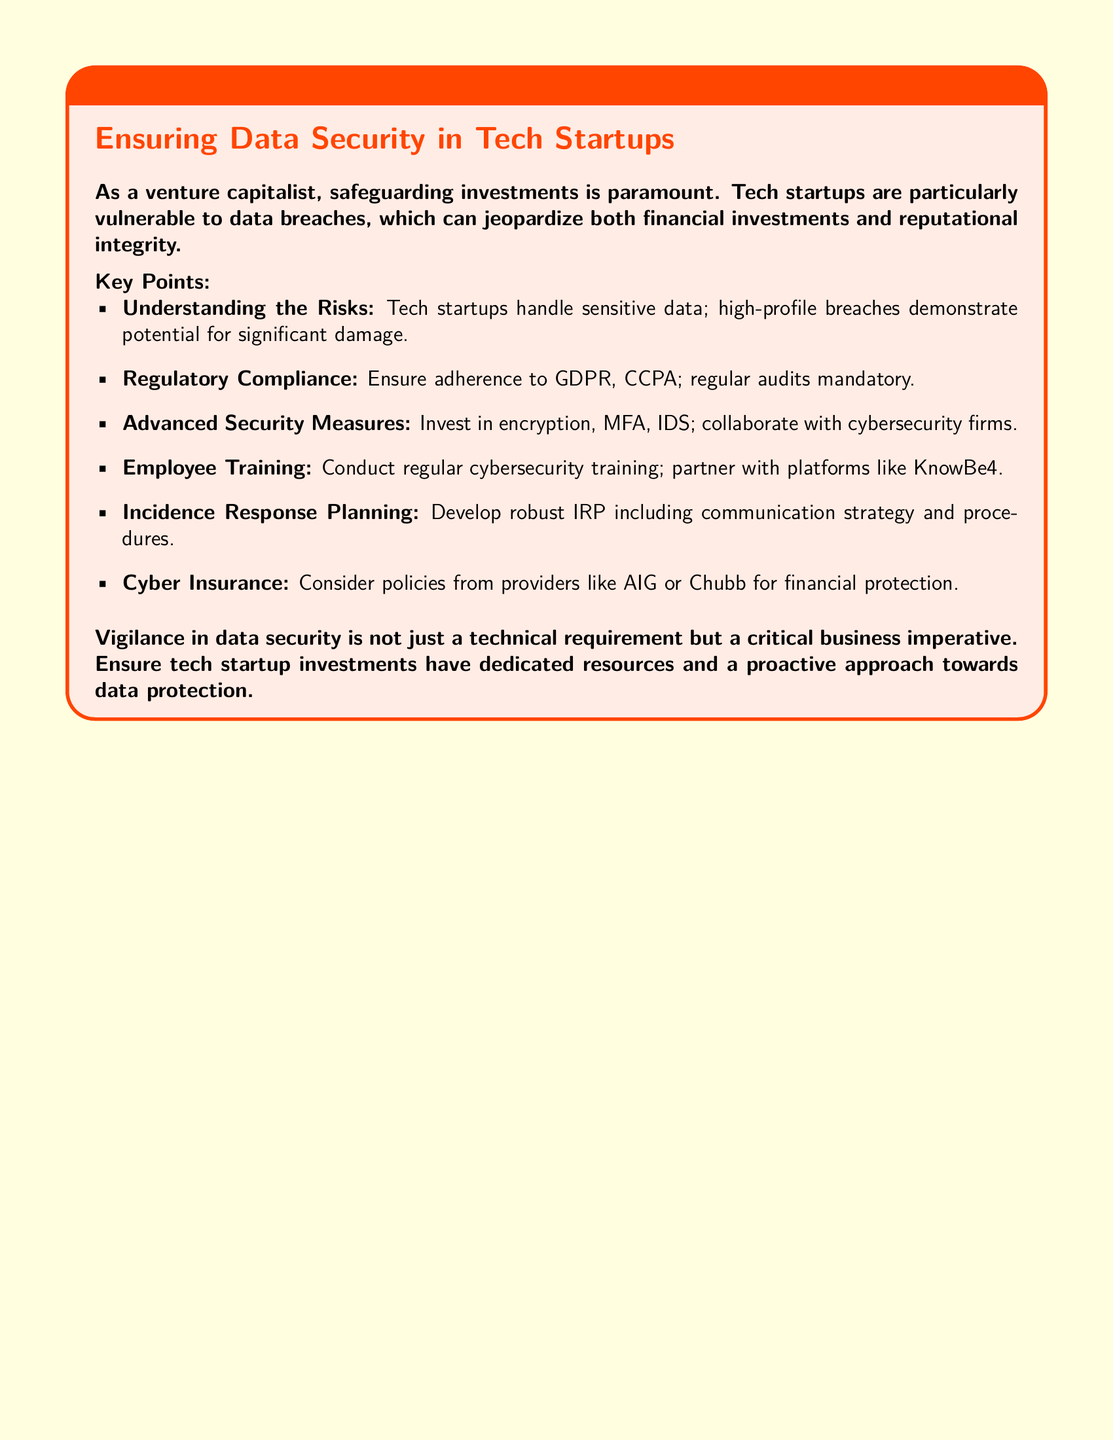What is the title of the document? The title of the document is stated in the title section at the top of the box.
Answer: Potential Data Breach Alert for Investors What does GDPR stand for? GDPR is mentioned as a regulatory compliance requirement within the document.
Answer: General Data Protection Regulation What type of insurance is suggested? The document discusses Cyber Insurance as part of data security measures.
Answer: Cyber Insurance What should be included in the Incident Response Planning? The document mentions the inclusion of a communication strategy and procedures in the IRP.
Answer: Communication strategy and procedures Which platform is recommended for employee training? The document suggests partnering with a specific platform for cybersecurity training for employees.
Answer: KnowBe4 What is the color theme of the document? The document uses specific colors, which can be identified in the background and title.
Answer: Light yellow How many key points are listed? The document includes a specific number of key points under the Key Points section.
Answer: Six Who is the primary audience of this warning label? The warning label is directly addressing a specific group involved in startups.
Answer: Investors What is one advanced security measure recommended? The document lists specific security measures available to startups for protection against data breaches.
Answer: MFA 